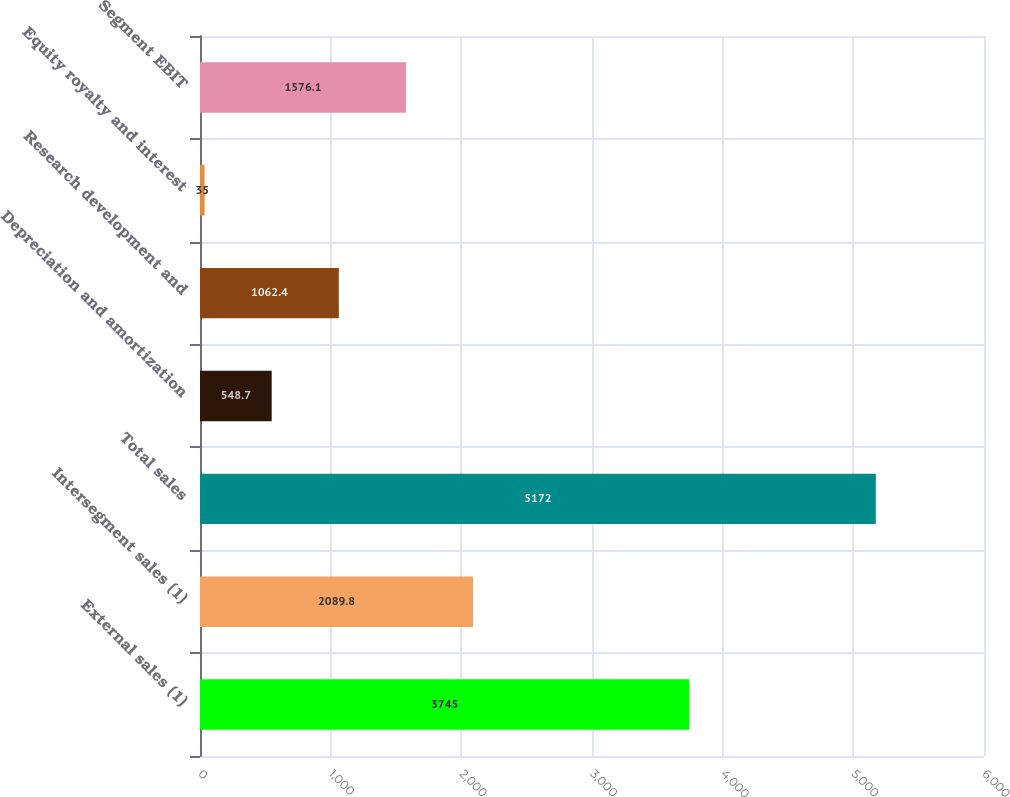<chart> <loc_0><loc_0><loc_500><loc_500><bar_chart><fcel>External sales (1)<fcel>Intersegment sales (1)<fcel>Total sales<fcel>Depreciation and amortization<fcel>Research development and<fcel>Equity royalty and interest<fcel>Segment EBIT<nl><fcel>3745<fcel>2089.8<fcel>5172<fcel>548.7<fcel>1062.4<fcel>35<fcel>1576.1<nl></chart> 